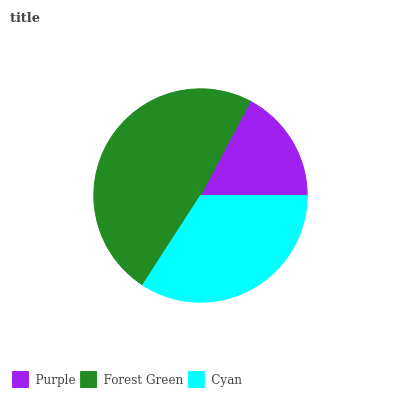Is Purple the minimum?
Answer yes or no. Yes. Is Forest Green the maximum?
Answer yes or no. Yes. Is Cyan the minimum?
Answer yes or no. No. Is Cyan the maximum?
Answer yes or no. No. Is Forest Green greater than Cyan?
Answer yes or no. Yes. Is Cyan less than Forest Green?
Answer yes or no. Yes. Is Cyan greater than Forest Green?
Answer yes or no. No. Is Forest Green less than Cyan?
Answer yes or no. No. Is Cyan the high median?
Answer yes or no. Yes. Is Cyan the low median?
Answer yes or no. Yes. Is Purple the high median?
Answer yes or no. No. Is Purple the low median?
Answer yes or no. No. 